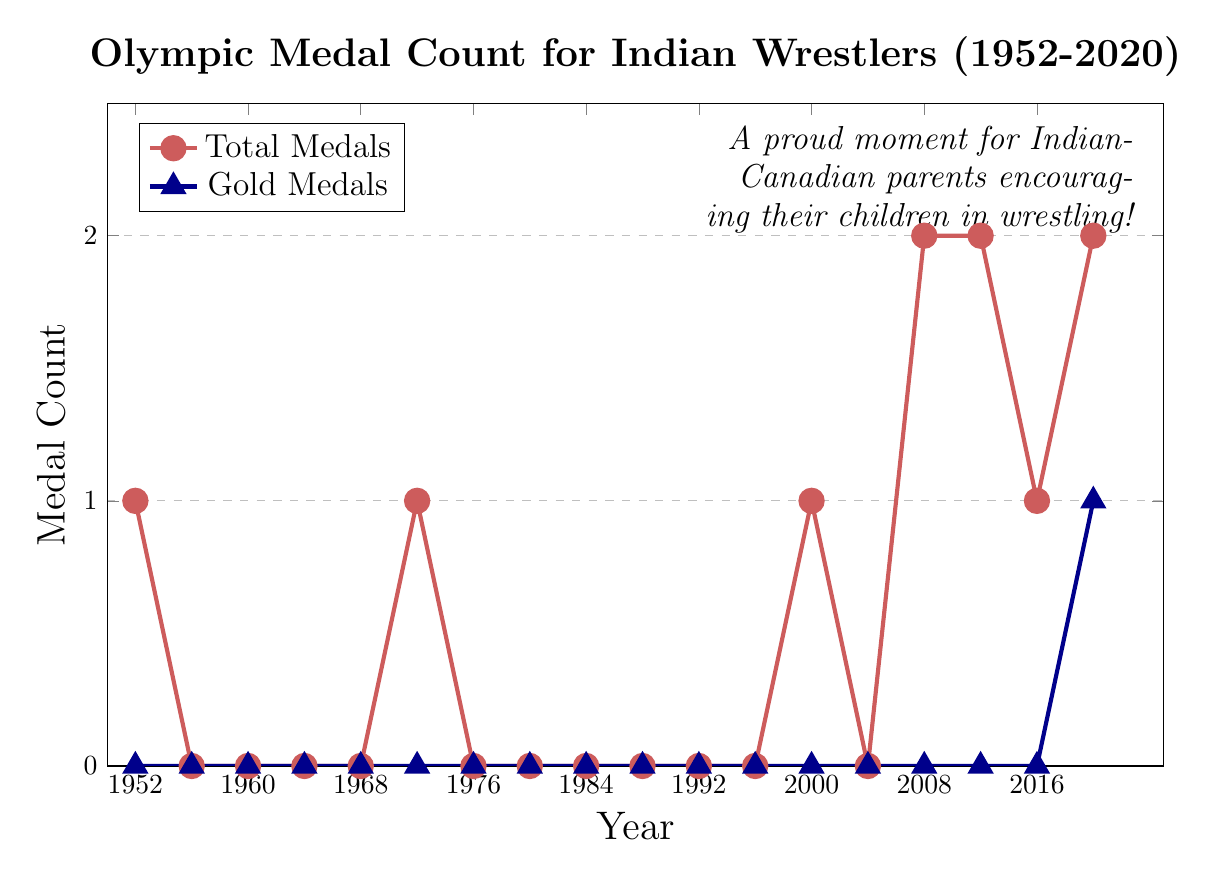Which years did Indian wrestlers win at least 1 medal? By observing the "Total Medals" line, each year where the value is at least 1 corresponds to a medal-winning year. These years appear to be 1952, 1972, 2000, 2008, 2012, 2016, and 2020.
Answer: 1952, 1972, 2000, 2008, 2012, 2016, 2020 How many gold medals did Indian wrestlers win in 2020? The "Gold Medals" line shows the count per year. For 2020, the mark is at 1, indicating 1 gold medal.
Answer: 1 Comparing 2008 to 2012, which year had more total medals? By checking the "Total Medals" line, both years (2008 and 2012) have 2 medals each.
Answer: Both years had equal medals What is the sum of total medals won in 2008 and 2020? From the "Total Medals" trend, 2008 has 2 medals and 2020 has 2 medals. Summing them gives 2 + 2 = 4.
Answer: 4 During which period did Indian wrestlers not win any medals at all? By examining the "Total Medals" graph, there is a long gap from 1956 to 1968, then from 1976 to 1996, and 2004, showing 0 medals.
Answer: 1956 to 1968, 1976 to 1996, 2004 Are there any years where Indian wrestlers won a gold medal but no other types of medals? Looking at the "Gold Medals" line and verifying that the "Total Medals" line has only 1 medal in that year. This occurs only in 2020 where they won exactly 1 gold medal with no other type of medal.
Answer: 2020 When was the first instance Indian wrestlers won multiple types of medals in the same year? The "Total Medals" and "Gold Medals" lines show different types per year. The first instance is in 2008 with 2 total medals (1 silver, 1 bronze).
Answer: 2008 What is the difference in the total number of medals between 1952 and 2020? In 1952, there was 1 total medal, and in 2020, there were 2 medals. The difference is 2 - 1 = 1.
Answer: 1 